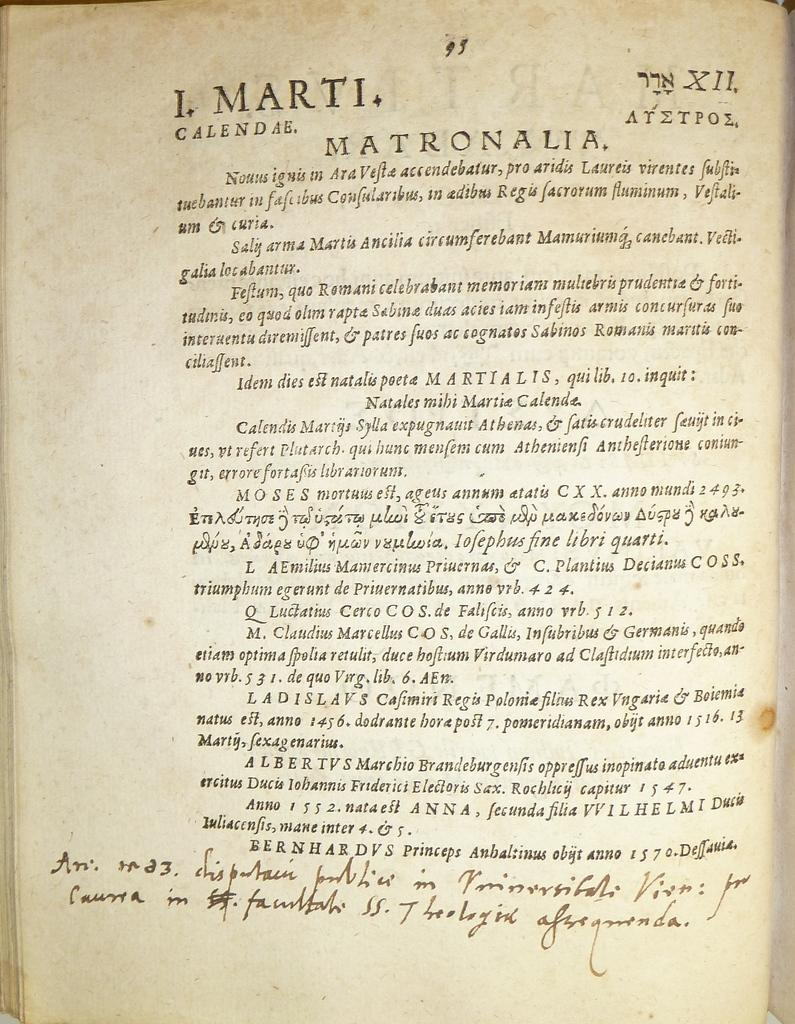<image>
Describe the image concisely. A book with handwriting on it is open to page 95. 